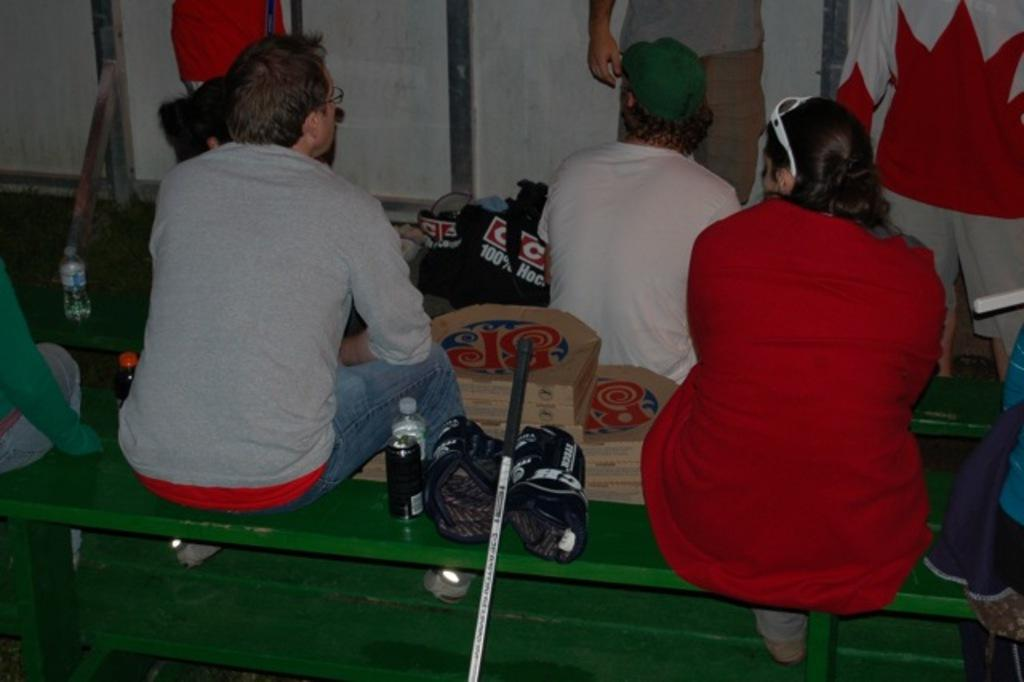What are the people in the image doing? The people in the image are seated and standing. What items can be seen for hydration in the image? There are water bottles visible in the image. What type of container is present in the image? There is a can in the image. What type of packaging is visible in the image? There are carton boxes in the image. What type of bait is being used to catch fish in the image? There is no mention of fishing or bait in the image; it features people seated and standing, water bottles, a can, and carton boxes. 